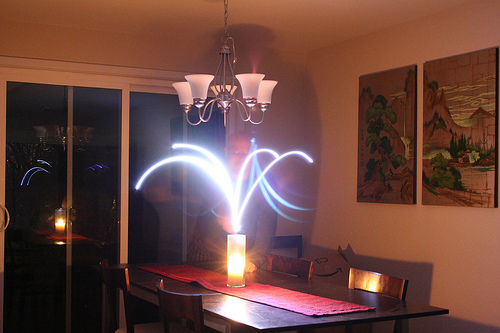<image>
Is the picture behind the chandelier? No. The picture is not behind the chandelier. From this viewpoint, the picture appears to be positioned elsewhere in the scene. 